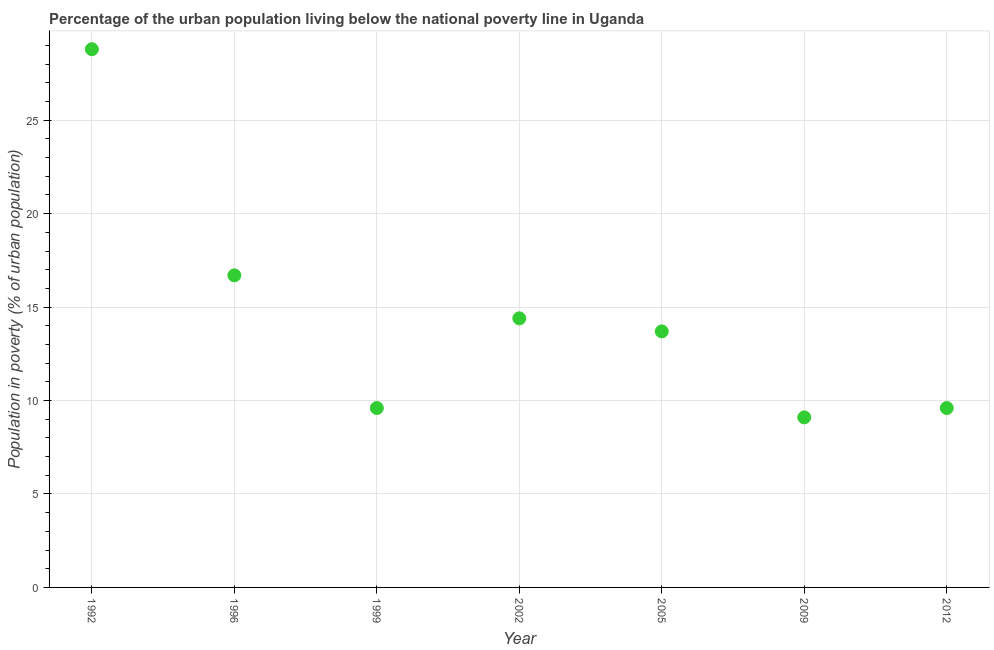Across all years, what is the maximum percentage of urban population living below poverty line?
Provide a succinct answer. 28.8. In which year was the percentage of urban population living below poverty line minimum?
Provide a short and direct response. 2009. What is the sum of the percentage of urban population living below poverty line?
Give a very brief answer. 101.9. What is the difference between the percentage of urban population living below poverty line in 1992 and 2012?
Give a very brief answer. 19.2. What is the average percentage of urban population living below poverty line per year?
Provide a succinct answer. 14.56. In how many years, is the percentage of urban population living below poverty line greater than 12 %?
Offer a terse response. 4. What is the ratio of the percentage of urban population living below poverty line in 1996 to that in 2002?
Your response must be concise. 1.16. What is the difference between the highest and the second highest percentage of urban population living below poverty line?
Offer a very short reply. 12.1. Is the sum of the percentage of urban population living below poverty line in 1992 and 2012 greater than the maximum percentage of urban population living below poverty line across all years?
Provide a short and direct response. Yes. What is the difference between the highest and the lowest percentage of urban population living below poverty line?
Provide a succinct answer. 19.7. In how many years, is the percentage of urban population living below poverty line greater than the average percentage of urban population living below poverty line taken over all years?
Make the answer very short. 2. How many years are there in the graph?
Make the answer very short. 7. What is the difference between two consecutive major ticks on the Y-axis?
Keep it short and to the point. 5. Does the graph contain grids?
Your response must be concise. Yes. What is the title of the graph?
Your answer should be very brief. Percentage of the urban population living below the national poverty line in Uganda. What is the label or title of the Y-axis?
Ensure brevity in your answer.  Population in poverty (% of urban population). What is the Population in poverty (% of urban population) in 1992?
Your response must be concise. 28.8. What is the Population in poverty (% of urban population) in 1999?
Your answer should be compact. 9.6. What is the Population in poverty (% of urban population) in 2002?
Give a very brief answer. 14.4. What is the Population in poverty (% of urban population) in 2005?
Give a very brief answer. 13.7. What is the Population in poverty (% of urban population) in 2009?
Give a very brief answer. 9.1. What is the Population in poverty (% of urban population) in 2012?
Offer a very short reply. 9.6. What is the difference between the Population in poverty (% of urban population) in 1992 and 1996?
Your answer should be compact. 12.1. What is the difference between the Population in poverty (% of urban population) in 1992 and 2002?
Provide a succinct answer. 14.4. What is the difference between the Population in poverty (% of urban population) in 1992 and 2009?
Your answer should be very brief. 19.7. What is the difference between the Population in poverty (% of urban population) in 1996 and 1999?
Your response must be concise. 7.1. What is the difference between the Population in poverty (% of urban population) in 1996 and 2005?
Provide a short and direct response. 3. What is the difference between the Population in poverty (% of urban population) in 1996 and 2012?
Offer a terse response. 7.1. What is the difference between the Population in poverty (% of urban population) in 1999 and 2005?
Your answer should be very brief. -4.1. What is the difference between the Population in poverty (% of urban population) in 2002 and 2009?
Your answer should be compact. 5.3. What is the difference between the Population in poverty (% of urban population) in 2005 and 2009?
Provide a short and direct response. 4.6. What is the difference between the Population in poverty (% of urban population) in 2005 and 2012?
Offer a terse response. 4.1. What is the ratio of the Population in poverty (% of urban population) in 1992 to that in 1996?
Provide a succinct answer. 1.73. What is the ratio of the Population in poverty (% of urban population) in 1992 to that in 2002?
Your answer should be very brief. 2. What is the ratio of the Population in poverty (% of urban population) in 1992 to that in 2005?
Offer a very short reply. 2.1. What is the ratio of the Population in poverty (% of urban population) in 1992 to that in 2009?
Your answer should be compact. 3.17. What is the ratio of the Population in poverty (% of urban population) in 1996 to that in 1999?
Offer a very short reply. 1.74. What is the ratio of the Population in poverty (% of urban population) in 1996 to that in 2002?
Provide a short and direct response. 1.16. What is the ratio of the Population in poverty (% of urban population) in 1996 to that in 2005?
Give a very brief answer. 1.22. What is the ratio of the Population in poverty (% of urban population) in 1996 to that in 2009?
Make the answer very short. 1.83. What is the ratio of the Population in poverty (% of urban population) in 1996 to that in 2012?
Your answer should be very brief. 1.74. What is the ratio of the Population in poverty (% of urban population) in 1999 to that in 2002?
Your answer should be very brief. 0.67. What is the ratio of the Population in poverty (% of urban population) in 1999 to that in 2005?
Provide a succinct answer. 0.7. What is the ratio of the Population in poverty (% of urban population) in 1999 to that in 2009?
Offer a very short reply. 1.05. What is the ratio of the Population in poverty (% of urban population) in 1999 to that in 2012?
Your response must be concise. 1. What is the ratio of the Population in poverty (% of urban population) in 2002 to that in 2005?
Keep it short and to the point. 1.05. What is the ratio of the Population in poverty (% of urban population) in 2002 to that in 2009?
Provide a succinct answer. 1.58. What is the ratio of the Population in poverty (% of urban population) in 2005 to that in 2009?
Provide a short and direct response. 1.5. What is the ratio of the Population in poverty (% of urban population) in 2005 to that in 2012?
Offer a very short reply. 1.43. What is the ratio of the Population in poverty (% of urban population) in 2009 to that in 2012?
Make the answer very short. 0.95. 